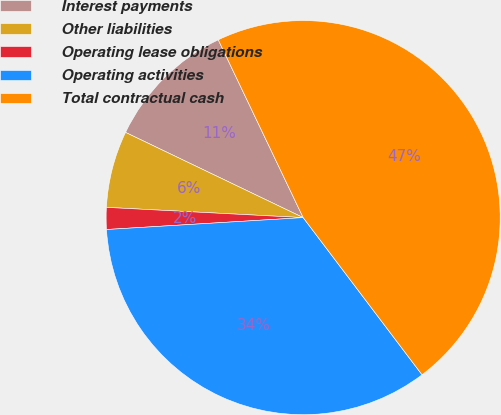Convert chart to OTSL. <chart><loc_0><loc_0><loc_500><loc_500><pie_chart><fcel>Interest payments<fcel>Other liabilities<fcel>Operating lease obligations<fcel>Operating activities<fcel>Total contractual cash<nl><fcel>10.79%<fcel>6.29%<fcel>1.79%<fcel>34.34%<fcel>46.78%<nl></chart> 